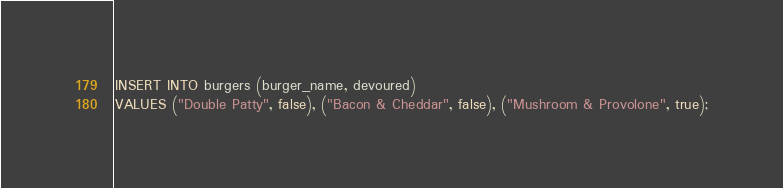<code> <loc_0><loc_0><loc_500><loc_500><_SQL_>
INSERT INTO burgers (burger_name, devoured)
VALUES ("Double Patty", false), ("Bacon & Cheddar", false), ("Mushroom & Provolone", true);</code> 